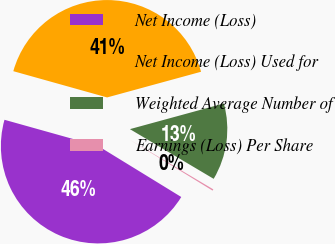Convert chart. <chart><loc_0><loc_0><loc_500><loc_500><pie_chart><fcel>Net Income (Loss)<fcel>Net Income (Loss) Used for<fcel>Weighted Average Number of<fcel>Earnings (Loss) Per Share<nl><fcel>45.58%<fcel>41.41%<fcel>12.77%<fcel>0.24%<nl></chart> 